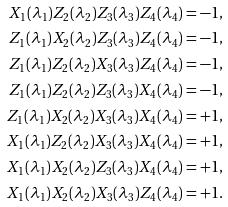<formula> <loc_0><loc_0><loc_500><loc_500>X _ { 1 } ( \lambda _ { 1 } ) Z _ { 2 } ( \lambda _ { 2 } ) Z _ { 3 } ( \lambda _ { 3 } ) Z _ { 4 } ( \lambda _ { 4 } ) & = - 1 , \\ Z _ { 1 } ( \lambda _ { 1 } ) X _ { 2 } ( \lambda _ { 2 } ) Z _ { 3 } ( \lambda _ { 3 } ) Z _ { 4 } ( \lambda _ { 4 } ) & = - 1 , \\ Z _ { 1 } ( \lambda _ { 1 } ) Z _ { 2 } ( \lambda _ { 2 } ) X _ { 3 } ( \lambda _ { 3 } ) Z _ { 4 } ( \lambda _ { 4 } ) & = - 1 , \\ Z _ { 1 } ( \lambda _ { 1 } ) Z _ { 2 } ( \lambda _ { 2 } ) Z _ { 3 } ( \lambda _ { 3 } ) X _ { 4 } ( \lambda _ { 4 } ) & = - 1 , \\ Z _ { 1 } ( \lambda _ { 1 } ) X _ { 2 } ( \lambda _ { 2 } ) X _ { 3 } ( \lambda _ { 3 } ) X _ { 4 } ( \lambda _ { 4 } ) & = + 1 , \\ X _ { 1 } ( \lambda _ { 1 } ) Z _ { 2 } ( \lambda _ { 2 } ) X _ { 3 } ( \lambda _ { 3 } ) X _ { 4 } ( \lambda _ { 4 } ) & = + 1 , \\ X _ { 1 } ( \lambda _ { 1 } ) X _ { 2 } ( \lambda _ { 2 } ) Z _ { 3 } ( \lambda _ { 3 } ) X _ { 4 } ( \lambda _ { 4 } ) & = + 1 , \\ X _ { 1 } ( \lambda _ { 1 } ) X _ { 2 } ( \lambda _ { 2 } ) X _ { 3 } ( \lambda _ { 3 } ) Z _ { 4 } ( \lambda _ { 4 } ) & = + 1 .</formula> 